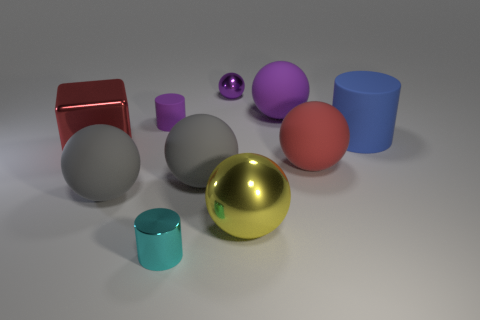Subtract all purple spheres. How many were subtracted if there are1purple spheres left? 1 Subtract all red spheres. How many spheres are left? 5 Subtract all purple cylinders. How many purple balls are left? 2 Subtract all gray spheres. How many spheres are left? 4 Subtract all balls. How many objects are left? 4 Subtract all green cylinders. Subtract all purple spheres. How many cylinders are left? 3 Add 7 tiny cylinders. How many tiny cylinders are left? 9 Add 2 green shiny blocks. How many green shiny blocks exist? 2 Subtract 1 purple balls. How many objects are left? 9 Subtract all large yellow metallic balls. Subtract all large metallic blocks. How many objects are left? 8 